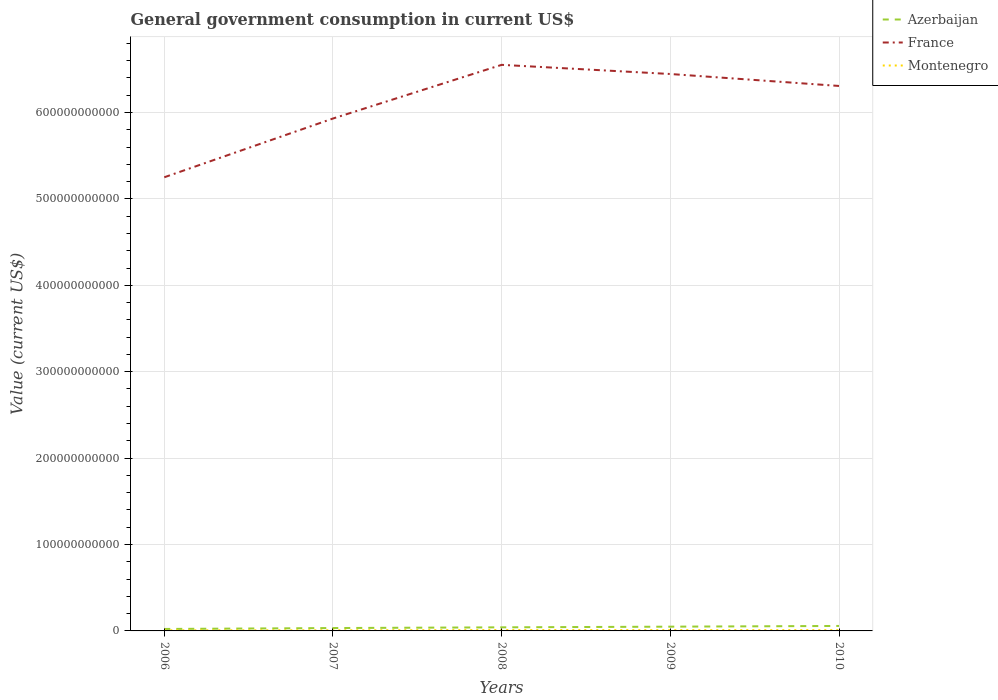Does the line corresponding to Azerbaijan intersect with the line corresponding to France?
Make the answer very short. No. Is the number of lines equal to the number of legend labels?
Your response must be concise. Yes. Across all years, what is the maximum government conusmption in Montenegro?
Give a very brief answer. 7.28e+08. What is the total government conusmption in Montenegro in the graph?
Your answer should be compact. -1.76e+08. What is the difference between the highest and the second highest government conusmption in France?
Your response must be concise. 1.30e+11. What is the difference between the highest and the lowest government conusmption in Montenegro?
Your response must be concise. 3. Is the government conusmption in Montenegro strictly greater than the government conusmption in Azerbaijan over the years?
Make the answer very short. Yes. What is the difference between two consecutive major ticks on the Y-axis?
Give a very brief answer. 1.00e+11. Does the graph contain any zero values?
Ensure brevity in your answer.  No. Where does the legend appear in the graph?
Keep it short and to the point. Top right. How many legend labels are there?
Offer a very short reply. 3. What is the title of the graph?
Offer a terse response. General government consumption in current US$. Does "Northern Mariana Islands" appear as one of the legend labels in the graph?
Ensure brevity in your answer.  No. What is the label or title of the Y-axis?
Give a very brief answer. Value (current US$). What is the Value (current US$) of Azerbaijan in 2006?
Offer a very short reply. 2.27e+09. What is the Value (current US$) of France in 2006?
Your answer should be very brief. 5.25e+11. What is the Value (current US$) of Montenegro in 2006?
Your answer should be compact. 7.28e+08. What is the Value (current US$) of Azerbaijan in 2007?
Provide a succinct answer. 3.33e+09. What is the Value (current US$) of France in 2007?
Your response must be concise. 5.93e+11. What is the Value (current US$) in Montenegro in 2007?
Provide a succinct answer. 7.38e+08. What is the Value (current US$) of Azerbaijan in 2008?
Make the answer very short. 4.15e+09. What is the Value (current US$) of France in 2008?
Keep it short and to the point. 6.55e+11. What is the Value (current US$) of Montenegro in 2008?
Your answer should be compact. 1.02e+09. What is the Value (current US$) of Azerbaijan in 2009?
Your response must be concise. 4.93e+09. What is the Value (current US$) of France in 2009?
Ensure brevity in your answer.  6.45e+11. What is the Value (current US$) of Montenegro in 2009?
Offer a terse response. 9.19e+08. What is the Value (current US$) in Azerbaijan in 2010?
Offer a terse response. 5.76e+09. What is the Value (current US$) in France in 2010?
Ensure brevity in your answer.  6.31e+11. What is the Value (current US$) of Montenegro in 2010?
Provide a short and direct response. 9.14e+08. Across all years, what is the maximum Value (current US$) of Azerbaijan?
Keep it short and to the point. 5.76e+09. Across all years, what is the maximum Value (current US$) of France?
Your answer should be very brief. 6.55e+11. Across all years, what is the maximum Value (current US$) in Montenegro?
Ensure brevity in your answer.  1.02e+09. Across all years, what is the minimum Value (current US$) of Azerbaijan?
Offer a terse response. 2.27e+09. Across all years, what is the minimum Value (current US$) in France?
Your answer should be compact. 5.25e+11. Across all years, what is the minimum Value (current US$) in Montenegro?
Your response must be concise. 7.28e+08. What is the total Value (current US$) in Azerbaijan in the graph?
Your response must be concise. 2.04e+1. What is the total Value (current US$) in France in the graph?
Keep it short and to the point. 3.05e+12. What is the total Value (current US$) of Montenegro in the graph?
Ensure brevity in your answer.  4.32e+09. What is the difference between the Value (current US$) of Azerbaijan in 2006 and that in 2007?
Your answer should be very brief. -1.06e+09. What is the difference between the Value (current US$) in France in 2006 and that in 2007?
Offer a very short reply. -6.80e+1. What is the difference between the Value (current US$) of Montenegro in 2006 and that in 2007?
Give a very brief answer. -1.05e+07. What is the difference between the Value (current US$) of Azerbaijan in 2006 and that in 2008?
Make the answer very short. -1.88e+09. What is the difference between the Value (current US$) of France in 2006 and that in 2008?
Give a very brief answer. -1.30e+11. What is the difference between the Value (current US$) of Montenegro in 2006 and that in 2008?
Offer a terse response. -2.95e+08. What is the difference between the Value (current US$) in Azerbaijan in 2006 and that in 2009?
Your answer should be very brief. -2.65e+09. What is the difference between the Value (current US$) of France in 2006 and that in 2009?
Provide a succinct answer. -1.20e+11. What is the difference between the Value (current US$) of Montenegro in 2006 and that in 2009?
Provide a short and direct response. -1.91e+08. What is the difference between the Value (current US$) in Azerbaijan in 2006 and that in 2010?
Provide a short and direct response. -3.48e+09. What is the difference between the Value (current US$) in France in 2006 and that in 2010?
Offer a terse response. -1.06e+11. What is the difference between the Value (current US$) of Montenegro in 2006 and that in 2010?
Your response must be concise. -1.87e+08. What is the difference between the Value (current US$) of Azerbaijan in 2007 and that in 2008?
Your answer should be very brief. -8.22e+08. What is the difference between the Value (current US$) in France in 2007 and that in 2008?
Your answer should be very brief. -6.21e+1. What is the difference between the Value (current US$) of Montenegro in 2007 and that in 2008?
Give a very brief answer. -2.84e+08. What is the difference between the Value (current US$) of Azerbaijan in 2007 and that in 2009?
Your response must be concise. -1.60e+09. What is the difference between the Value (current US$) in France in 2007 and that in 2009?
Make the answer very short. -5.15e+1. What is the difference between the Value (current US$) of Montenegro in 2007 and that in 2009?
Your answer should be compact. -1.81e+08. What is the difference between the Value (current US$) in Azerbaijan in 2007 and that in 2010?
Keep it short and to the point. -2.43e+09. What is the difference between the Value (current US$) of France in 2007 and that in 2010?
Ensure brevity in your answer.  -3.77e+1. What is the difference between the Value (current US$) of Montenegro in 2007 and that in 2010?
Give a very brief answer. -1.76e+08. What is the difference between the Value (current US$) in Azerbaijan in 2008 and that in 2009?
Your response must be concise. -7.77e+08. What is the difference between the Value (current US$) in France in 2008 and that in 2009?
Ensure brevity in your answer.  1.06e+1. What is the difference between the Value (current US$) in Montenegro in 2008 and that in 2009?
Ensure brevity in your answer.  1.04e+08. What is the difference between the Value (current US$) of Azerbaijan in 2008 and that in 2010?
Offer a terse response. -1.61e+09. What is the difference between the Value (current US$) of France in 2008 and that in 2010?
Provide a succinct answer. 2.44e+1. What is the difference between the Value (current US$) of Montenegro in 2008 and that in 2010?
Your response must be concise. 1.08e+08. What is the difference between the Value (current US$) of Azerbaijan in 2009 and that in 2010?
Make the answer very short. -8.30e+08. What is the difference between the Value (current US$) of France in 2009 and that in 2010?
Provide a short and direct response. 1.38e+1. What is the difference between the Value (current US$) of Montenegro in 2009 and that in 2010?
Your answer should be very brief. 4.42e+06. What is the difference between the Value (current US$) in Azerbaijan in 2006 and the Value (current US$) in France in 2007?
Provide a short and direct response. -5.91e+11. What is the difference between the Value (current US$) in Azerbaijan in 2006 and the Value (current US$) in Montenegro in 2007?
Give a very brief answer. 1.53e+09. What is the difference between the Value (current US$) in France in 2006 and the Value (current US$) in Montenegro in 2007?
Give a very brief answer. 5.24e+11. What is the difference between the Value (current US$) in Azerbaijan in 2006 and the Value (current US$) in France in 2008?
Keep it short and to the point. -6.53e+11. What is the difference between the Value (current US$) of Azerbaijan in 2006 and the Value (current US$) of Montenegro in 2008?
Make the answer very short. 1.25e+09. What is the difference between the Value (current US$) of France in 2006 and the Value (current US$) of Montenegro in 2008?
Provide a short and direct response. 5.24e+11. What is the difference between the Value (current US$) in Azerbaijan in 2006 and the Value (current US$) in France in 2009?
Your answer should be compact. -6.42e+11. What is the difference between the Value (current US$) in Azerbaijan in 2006 and the Value (current US$) in Montenegro in 2009?
Your answer should be very brief. 1.35e+09. What is the difference between the Value (current US$) of France in 2006 and the Value (current US$) of Montenegro in 2009?
Ensure brevity in your answer.  5.24e+11. What is the difference between the Value (current US$) of Azerbaijan in 2006 and the Value (current US$) of France in 2010?
Give a very brief answer. -6.28e+11. What is the difference between the Value (current US$) of Azerbaijan in 2006 and the Value (current US$) of Montenegro in 2010?
Offer a terse response. 1.36e+09. What is the difference between the Value (current US$) of France in 2006 and the Value (current US$) of Montenegro in 2010?
Provide a succinct answer. 5.24e+11. What is the difference between the Value (current US$) in Azerbaijan in 2007 and the Value (current US$) in France in 2008?
Ensure brevity in your answer.  -6.52e+11. What is the difference between the Value (current US$) of Azerbaijan in 2007 and the Value (current US$) of Montenegro in 2008?
Offer a very short reply. 2.31e+09. What is the difference between the Value (current US$) in France in 2007 and the Value (current US$) in Montenegro in 2008?
Offer a terse response. 5.92e+11. What is the difference between the Value (current US$) of Azerbaijan in 2007 and the Value (current US$) of France in 2009?
Give a very brief answer. -6.41e+11. What is the difference between the Value (current US$) of Azerbaijan in 2007 and the Value (current US$) of Montenegro in 2009?
Your answer should be compact. 2.41e+09. What is the difference between the Value (current US$) in France in 2007 and the Value (current US$) in Montenegro in 2009?
Give a very brief answer. 5.92e+11. What is the difference between the Value (current US$) of Azerbaijan in 2007 and the Value (current US$) of France in 2010?
Provide a short and direct response. -6.27e+11. What is the difference between the Value (current US$) of Azerbaijan in 2007 and the Value (current US$) of Montenegro in 2010?
Make the answer very short. 2.41e+09. What is the difference between the Value (current US$) in France in 2007 and the Value (current US$) in Montenegro in 2010?
Your answer should be compact. 5.92e+11. What is the difference between the Value (current US$) in Azerbaijan in 2008 and the Value (current US$) in France in 2009?
Offer a terse response. -6.40e+11. What is the difference between the Value (current US$) in Azerbaijan in 2008 and the Value (current US$) in Montenegro in 2009?
Offer a terse response. 3.23e+09. What is the difference between the Value (current US$) of France in 2008 and the Value (current US$) of Montenegro in 2009?
Your answer should be very brief. 6.54e+11. What is the difference between the Value (current US$) in Azerbaijan in 2008 and the Value (current US$) in France in 2010?
Give a very brief answer. -6.27e+11. What is the difference between the Value (current US$) in Azerbaijan in 2008 and the Value (current US$) in Montenegro in 2010?
Your answer should be compact. 3.24e+09. What is the difference between the Value (current US$) in France in 2008 and the Value (current US$) in Montenegro in 2010?
Your answer should be compact. 6.54e+11. What is the difference between the Value (current US$) of Azerbaijan in 2009 and the Value (current US$) of France in 2010?
Provide a succinct answer. -6.26e+11. What is the difference between the Value (current US$) in Azerbaijan in 2009 and the Value (current US$) in Montenegro in 2010?
Your answer should be very brief. 4.01e+09. What is the difference between the Value (current US$) in France in 2009 and the Value (current US$) in Montenegro in 2010?
Offer a very short reply. 6.44e+11. What is the average Value (current US$) of Azerbaijan per year?
Your answer should be very brief. 4.09e+09. What is the average Value (current US$) of France per year?
Make the answer very short. 6.10e+11. What is the average Value (current US$) in Montenegro per year?
Keep it short and to the point. 8.64e+08. In the year 2006, what is the difference between the Value (current US$) of Azerbaijan and Value (current US$) of France?
Provide a succinct answer. -5.23e+11. In the year 2006, what is the difference between the Value (current US$) of Azerbaijan and Value (current US$) of Montenegro?
Your answer should be compact. 1.54e+09. In the year 2006, what is the difference between the Value (current US$) in France and Value (current US$) in Montenegro?
Provide a short and direct response. 5.24e+11. In the year 2007, what is the difference between the Value (current US$) in Azerbaijan and Value (current US$) in France?
Offer a very short reply. -5.90e+11. In the year 2007, what is the difference between the Value (current US$) in Azerbaijan and Value (current US$) in Montenegro?
Keep it short and to the point. 2.59e+09. In the year 2007, what is the difference between the Value (current US$) in France and Value (current US$) in Montenegro?
Your answer should be very brief. 5.92e+11. In the year 2008, what is the difference between the Value (current US$) of Azerbaijan and Value (current US$) of France?
Give a very brief answer. -6.51e+11. In the year 2008, what is the difference between the Value (current US$) of Azerbaijan and Value (current US$) of Montenegro?
Make the answer very short. 3.13e+09. In the year 2008, what is the difference between the Value (current US$) of France and Value (current US$) of Montenegro?
Give a very brief answer. 6.54e+11. In the year 2009, what is the difference between the Value (current US$) in Azerbaijan and Value (current US$) in France?
Keep it short and to the point. -6.40e+11. In the year 2009, what is the difference between the Value (current US$) of Azerbaijan and Value (current US$) of Montenegro?
Offer a terse response. 4.01e+09. In the year 2009, what is the difference between the Value (current US$) of France and Value (current US$) of Montenegro?
Offer a terse response. 6.44e+11. In the year 2010, what is the difference between the Value (current US$) in Azerbaijan and Value (current US$) in France?
Your answer should be very brief. -6.25e+11. In the year 2010, what is the difference between the Value (current US$) of Azerbaijan and Value (current US$) of Montenegro?
Your answer should be compact. 4.84e+09. In the year 2010, what is the difference between the Value (current US$) in France and Value (current US$) in Montenegro?
Offer a very short reply. 6.30e+11. What is the ratio of the Value (current US$) in Azerbaijan in 2006 to that in 2007?
Offer a terse response. 0.68. What is the ratio of the Value (current US$) of France in 2006 to that in 2007?
Your answer should be very brief. 0.89. What is the ratio of the Value (current US$) of Montenegro in 2006 to that in 2007?
Ensure brevity in your answer.  0.99. What is the ratio of the Value (current US$) in Azerbaijan in 2006 to that in 2008?
Make the answer very short. 0.55. What is the ratio of the Value (current US$) of France in 2006 to that in 2008?
Provide a short and direct response. 0.8. What is the ratio of the Value (current US$) in Montenegro in 2006 to that in 2008?
Provide a short and direct response. 0.71. What is the ratio of the Value (current US$) in Azerbaijan in 2006 to that in 2009?
Make the answer very short. 0.46. What is the ratio of the Value (current US$) of France in 2006 to that in 2009?
Make the answer very short. 0.81. What is the ratio of the Value (current US$) in Montenegro in 2006 to that in 2009?
Your answer should be very brief. 0.79. What is the ratio of the Value (current US$) of Azerbaijan in 2006 to that in 2010?
Your response must be concise. 0.39. What is the ratio of the Value (current US$) in France in 2006 to that in 2010?
Your answer should be very brief. 0.83. What is the ratio of the Value (current US$) of Montenegro in 2006 to that in 2010?
Your response must be concise. 0.8. What is the ratio of the Value (current US$) in Azerbaijan in 2007 to that in 2008?
Offer a terse response. 0.8. What is the ratio of the Value (current US$) of France in 2007 to that in 2008?
Ensure brevity in your answer.  0.91. What is the ratio of the Value (current US$) of Montenegro in 2007 to that in 2008?
Your answer should be compact. 0.72. What is the ratio of the Value (current US$) in Azerbaijan in 2007 to that in 2009?
Ensure brevity in your answer.  0.68. What is the ratio of the Value (current US$) in France in 2007 to that in 2009?
Provide a succinct answer. 0.92. What is the ratio of the Value (current US$) in Montenegro in 2007 to that in 2009?
Offer a very short reply. 0.8. What is the ratio of the Value (current US$) in Azerbaijan in 2007 to that in 2010?
Provide a succinct answer. 0.58. What is the ratio of the Value (current US$) of France in 2007 to that in 2010?
Ensure brevity in your answer.  0.94. What is the ratio of the Value (current US$) in Montenegro in 2007 to that in 2010?
Provide a short and direct response. 0.81. What is the ratio of the Value (current US$) in Azerbaijan in 2008 to that in 2009?
Your answer should be compact. 0.84. What is the ratio of the Value (current US$) in France in 2008 to that in 2009?
Your answer should be compact. 1.02. What is the ratio of the Value (current US$) of Montenegro in 2008 to that in 2009?
Ensure brevity in your answer.  1.11. What is the ratio of the Value (current US$) in Azerbaijan in 2008 to that in 2010?
Keep it short and to the point. 0.72. What is the ratio of the Value (current US$) of France in 2008 to that in 2010?
Make the answer very short. 1.04. What is the ratio of the Value (current US$) in Montenegro in 2008 to that in 2010?
Make the answer very short. 1.12. What is the ratio of the Value (current US$) of Azerbaijan in 2009 to that in 2010?
Offer a terse response. 0.86. What is the ratio of the Value (current US$) of France in 2009 to that in 2010?
Offer a terse response. 1.02. What is the difference between the highest and the second highest Value (current US$) in Azerbaijan?
Keep it short and to the point. 8.30e+08. What is the difference between the highest and the second highest Value (current US$) of France?
Make the answer very short. 1.06e+1. What is the difference between the highest and the second highest Value (current US$) in Montenegro?
Make the answer very short. 1.04e+08. What is the difference between the highest and the lowest Value (current US$) in Azerbaijan?
Keep it short and to the point. 3.48e+09. What is the difference between the highest and the lowest Value (current US$) in France?
Ensure brevity in your answer.  1.30e+11. What is the difference between the highest and the lowest Value (current US$) in Montenegro?
Make the answer very short. 2.95e+08. 